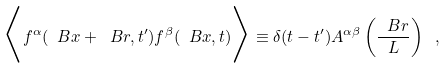<formula> <loc_0><loc_0><loc_500><loc_500>\Big < f ^ { \alpha } ( \ B x + \ B r , t ^ { \prime } ) f ^ { \beta } ( \ B x , t ) \Big > \equiv \delta ( t - t ^ { \prime } ) A ^ { \alpha \beta } \left ( \frac { \ B r } { L } \right ) \ ,</formula> 